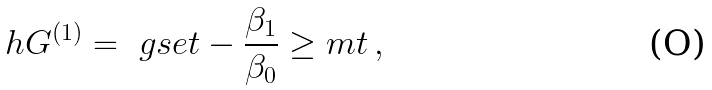Convert formula to latex. <formula><loc_0><loc_0><loc_500><loc_500>\ h G ^ { ( 1 ) } = \ g s e t - \frac { \beta _ { 1 } } { \beta _ { 0 } } \geq m t \, ,</formula> 